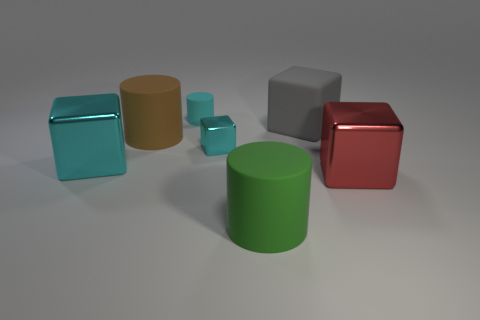There is another tiny thing that is the same color as the tiny metallic object; what is it made of?
Make the answer very short. Rubber. How many tiny matte objects are the same color as the tiny cube?
Keep it short and to the point. 1. What is the material of the cube that is behind the metallic thing behind the large cube to the left of the gray rubber thing?
Provide a short and direct response. Rubber. There is a rubber object that is on the right side of the large matte cylinder on the right side of the large brown cylinder; what color is it?
Give a very brief answer. Gray. How many small things are either blocks or brown cylinders?
Offer a very short reply. 1. What number of tiny cyan cubes are the same material as the big cyan block?
Make the answer very short. 1. There is a matte object that is in front of the large red thing; what size is it?
Offer a terse response. Large. There is a metal object that is in front of the big shiny cube to the left of the red block; what is its shape?
Your response must be concise. Cube. There is a object that is in front of the cube to the right of the large gray rubber block; how many red things are in front of it?
Your answer should be very brief. 0. Are there fewer big objects in front of the big brown cylinder than large brown objects?
Offer a terse response. No. 